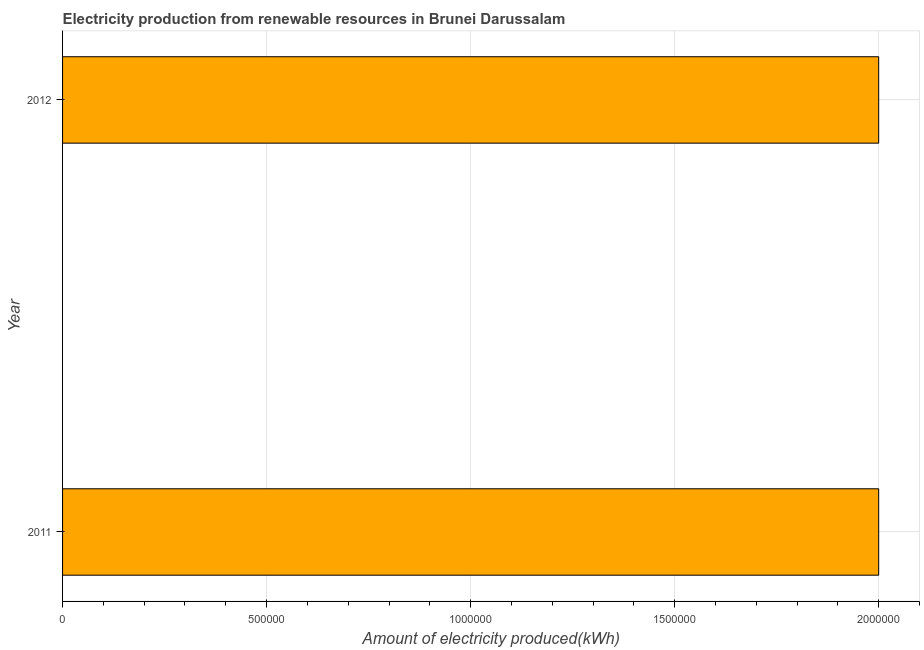Does the graph contain any zero values?
Your answer should be compact. No. What is the title of the graph?
Make the answer very short. Electricity production from renewable resources in Brunei Darussalam. What is the label or title of the X-axis?
Provide a short and direct response. Amount of electricity produced(kWh). What is the amount of electricity produced in 2012?
Your answer should be compact. 2.00e+06. Across all years, what is the maximum amount of electricity produced?
Keep it short and to the point. 2.00e+06. In which year was the amount of electricity produced maximum?
Provide a short and direct response. 2011. What is the average amount of electricity produced per year?
Ensure brevity in your answer.  2.00e+06. Do a majority of the years between 2011 and 2012 (inclusive) have amount of electricity produced greater than 1000000 kWh?
Keep it short and to the point. Yes. What is the ratio of the amount of electricity produced in 2011 to that in 2012?
Keep it short and to the point. 1. In how many years, is the amount of electricity produced greater than the average amount of electricity produced taken over all years?
Make the answer very short. 0. How many bars are there?
Offer a very short reply. 2. What is the difference between two consecutive major ticks on the X-axis?
Ensure brevity in your answer.  5.00e+05. What is the Amount of electricity produced(kWh) of 2011?
Your response must be concise. 2.00e+06. What is the Amount of electricity produced(kWh) of 2012?
Your response must be concise. 2.00e+06. What is the difference between the Amount of electricity produced(kWh) in 2011 and 2012?
Give a very brief answer. 0. 